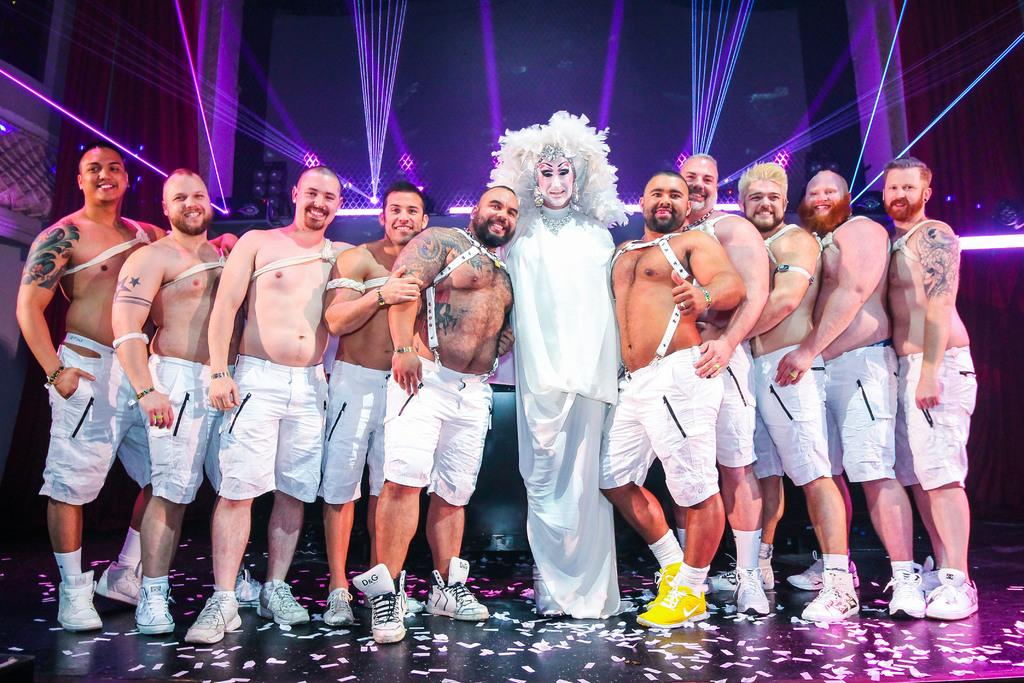What is happening in the image involving a group of people? The group of people are taking a photograph. Can you identify any unique features about one of the individuals in the group? One person in the group is wearing a different type of dress. What type of ticket is visible in the image? There is no ticket present in the image. Can you see any visible veins on the people in the image? The image does not provide enough detail to see veins on the people. 